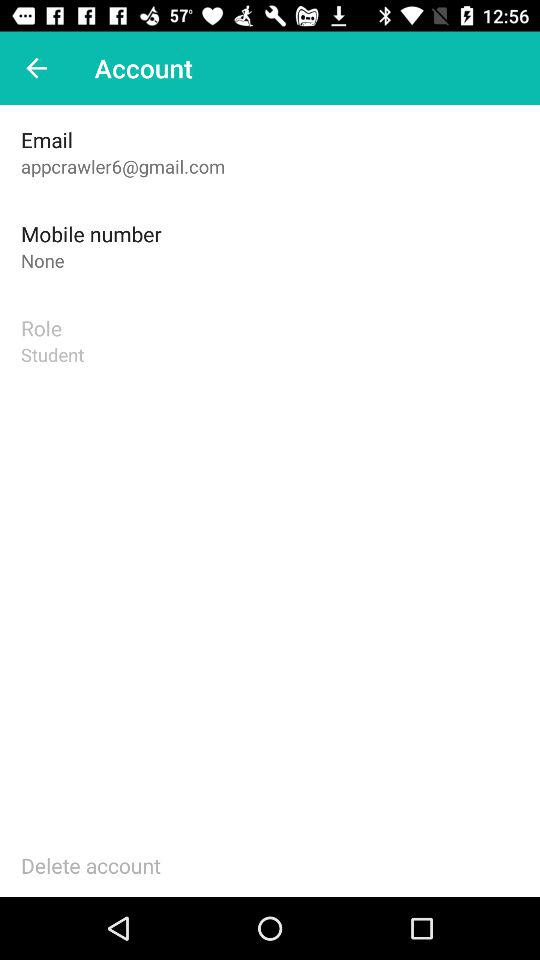What is the email address? The email address is appcrawler6@gmail.com. 